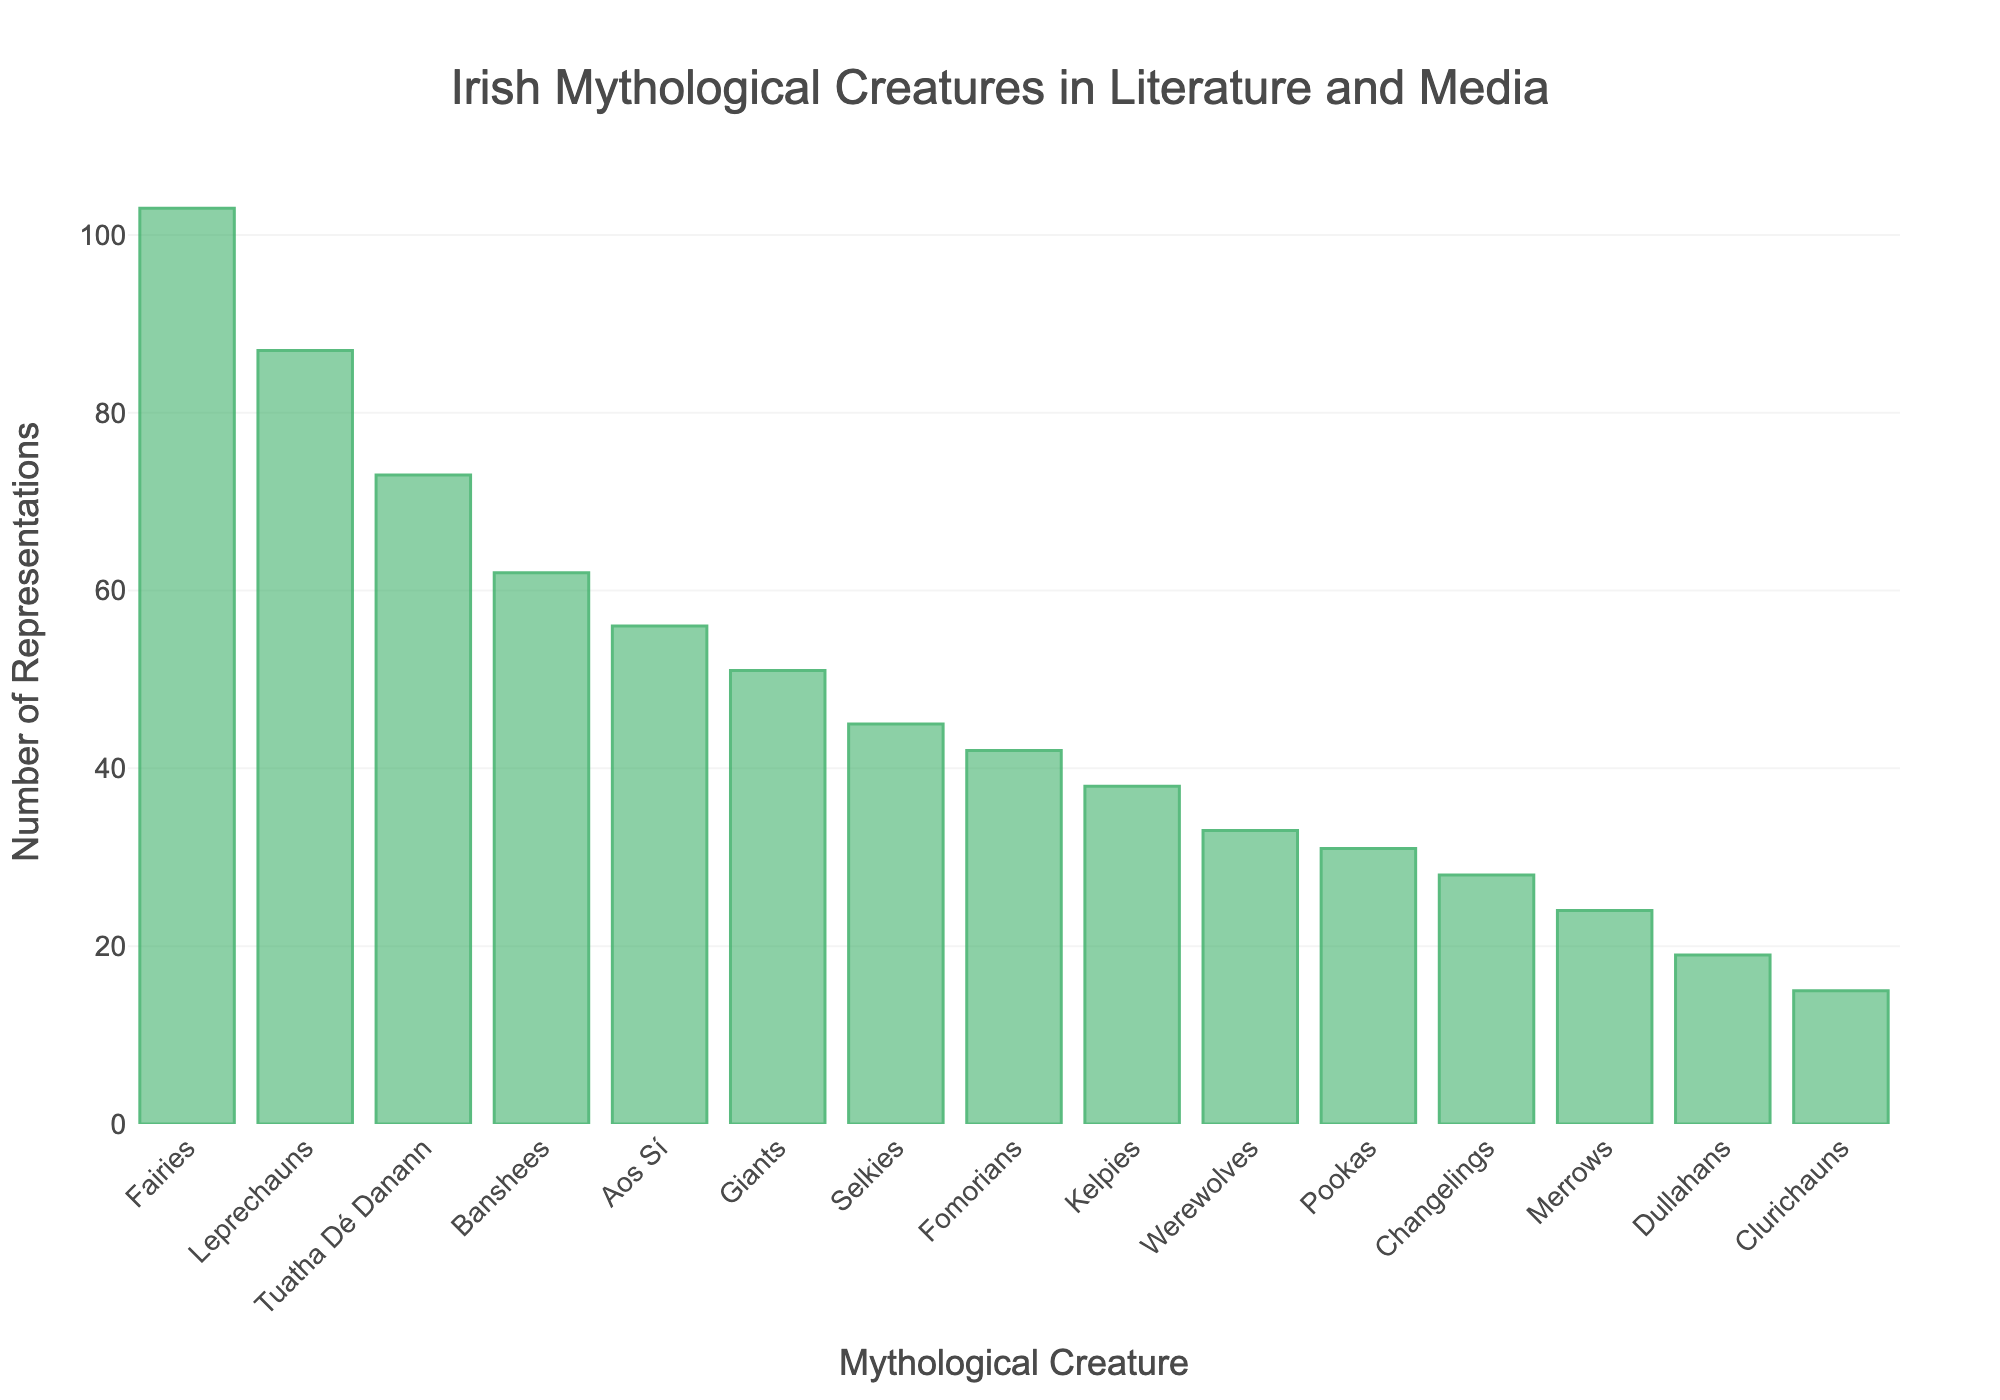Which mythological creature has the highest number of representations? By observing the heights of the bars, Fairies have the tallest bar, indicating the highest number of representations, which is 103.
Answer: Fairies Which mythological creature has the lowest number of representations? By looking at the bars, Clurichauns have the shortest bar, indicating the lowest number of representations, which is 15.
Answer: Clurichauns How many more representations do Leprechauns have compared to Dullahans? Leprechauns have 87 representations, and Dullahans have 19. The difference is calculated as 87 - 19 = 68.
Answer: 68 What is the total number of representations for Banshees, Merrows, and Werewolves? Summing the representations, Banshees have 62, Merrows have 24, and Werewolves have 33. The total is 62 + 24 + 33 = 119.
Answer: 119 What is the average number of representations for Leprechauns, Fairies, and Pookas? Adding the representations of Leprechauns (87), Fairies (103), and Pookas (31), we get 87 + 103 + 31 = 221. Dividing by 3, the average is 221/3 ≈ 73.67.
Answer: ~73.67 Are there more representations of Kelpies or Selkies? By comparing the heights of the bars, Kelpies have 38 representations, and Selkies have 45, so Selkies have more.
Answer: Selkies What is the sum of the representations for all creatures having less than 30 representations? Adding the representations of Changelings (28), Dullahans (19), Merrows (24), and Clurichauns (15), the total is 28 + 19 + 24 + 15 = 86.
Answer: 86 How does the number of representations of the Tuatha Dé Danann compare with that of the Giants? The Tuatha Dé Danann have 73 representations, while Giants have 51. Since 73 > 51, the Tuatha Dé Danann have more representations.
Answer: Tuatha Dé Danann Which creatures have representations between 40 and 60 inclusive? The creatures with the corresponding bars indicating representations between 40 and 60 are Banshees (62), Aos Sí (56), Fomorians (42), and Giants (51).
Answer: Banshees, Aos Sí, Fomorians, Giants 